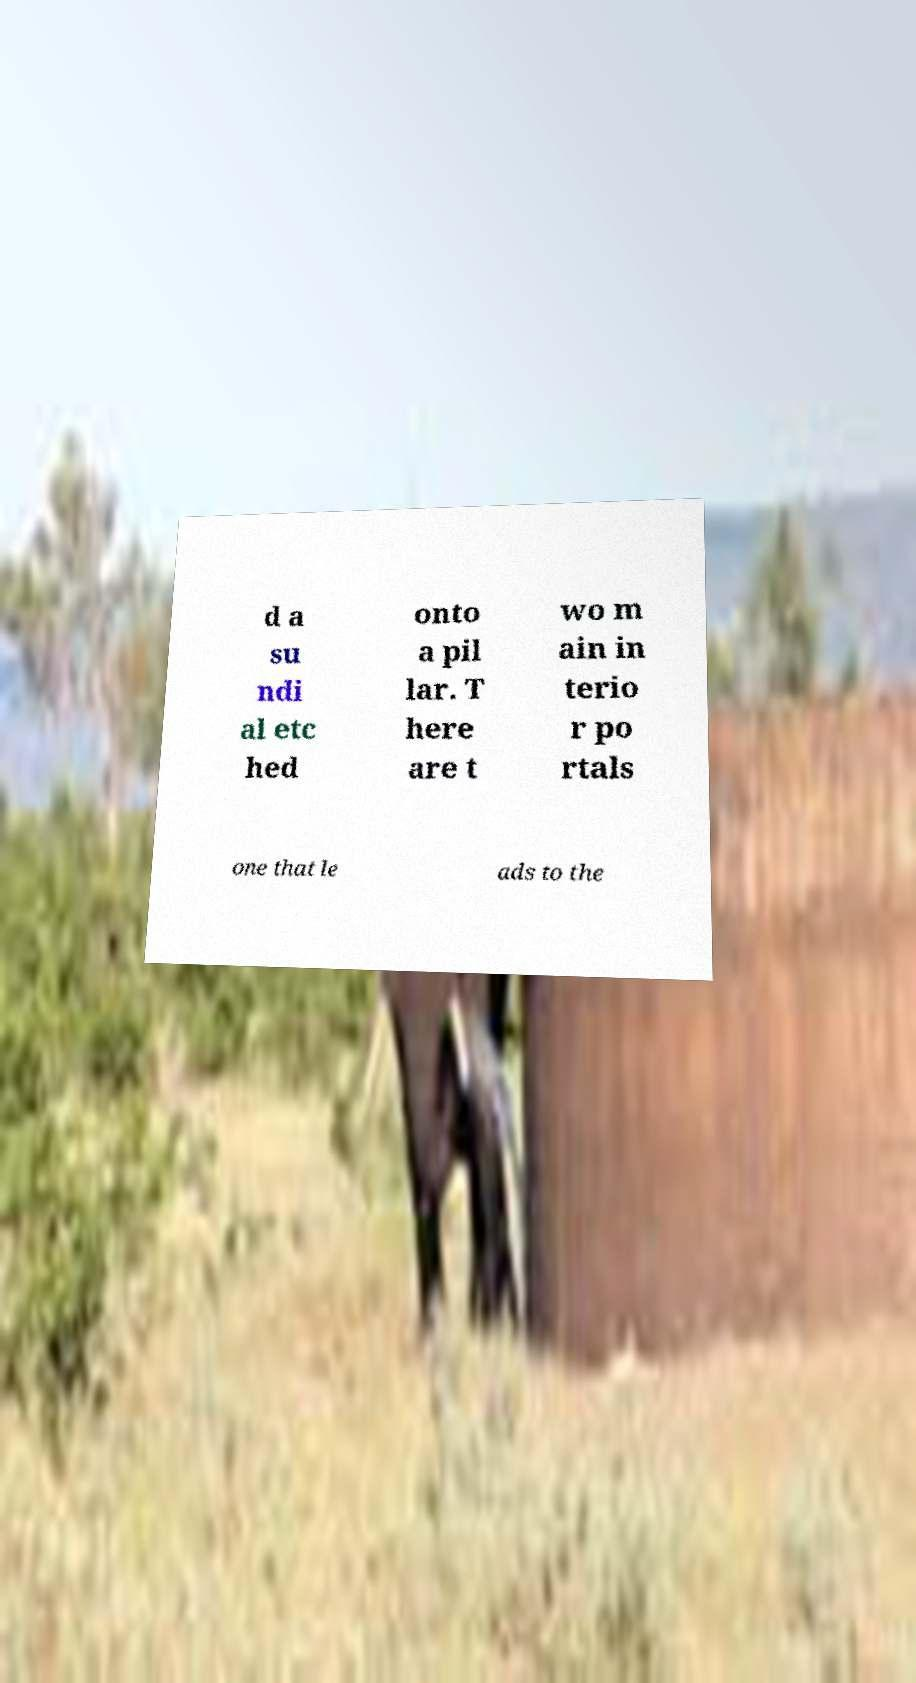I need the written content from this picture converted into text. Can you do that? d a su ndi al etc hed onto a pil lar. T here are t wo m ain in terio r po rtals one that le ads to the 